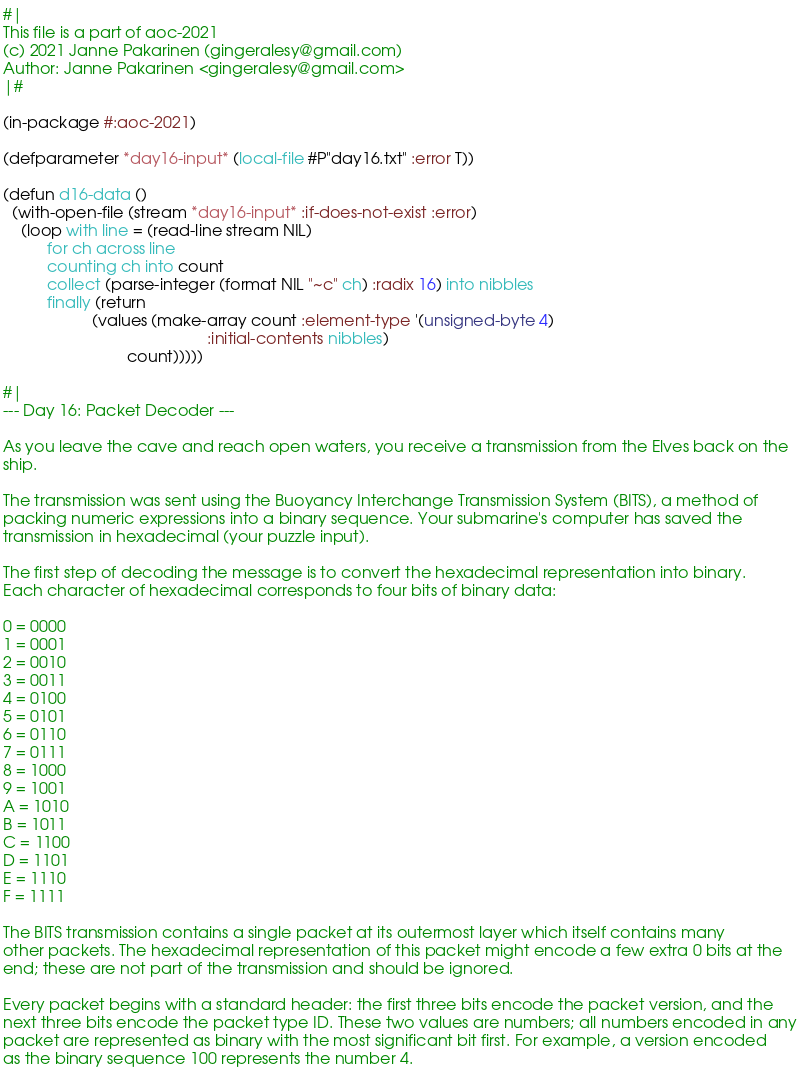<code> <loc_0><loc_0><loc_500><loc_500><_Lisp_>#|
This file is a part of aoc-2021
(c) 2021 Janne Pakarinen (gingeralesy@gmail.com)
Author: Janne Pakarinen <gingeralesy@gmail.com>
|#

(in-package #:aoc-2021)

(defparameter *day16-input* (local-file #P"day16.txt" :error T))

(defun d16-data ()
  (with-open-file (stream *day16-input* :if-does-not-exist :error)
    (loop with line = (read-line stream NIL)
          for ch across line
          counting ch into count
          collect (parse-integer (format NIL "~c" ch) :radix 16) into nibbles
          finally (return
                    (values (make-array count :element-type '(unsigned-byte 4)
                                              :initial-contents nibbles)
                            count)))))

#|
--- Day 16: Packet Decoder ---

As you leave the cave and reach open waters, you receive a transmission from the Elves back on the
ship.

The transmission was sent using the Buoyancy Interchange Transmission System (BITS), a method of
packing numeric expressions into a binary sequence. Your submarine's computer has saved the
transmission in hexadecimal (your puzzle input).

The first step of decoding the message is to convert the hexadecimal representation into binary.
Each character of hexadecimal corresponds to four bits of binary data:

0 = 0000
1 = 0001
2 = 0010
3 = 0011
4 = 0100
5 = 0101
6 = 0110
7 = 0111
8 = 1000
9 = 1001
A = 1010
B = 1011
C = 1100
D = 1101
E = 1110
F = 1111

The BITS transmission contains a single packet at its outermost layer which itself contains many
other packets. The hexadecimal representation of this packet might encode a few extra 0 bits at the
end; these are not part of the transmission and should be ignored.

Every packet begins with a standard header: the first three bits encode the packet version, and the
next three bits encode the packet type ID. These two values are numbers; all numbers encoded in any
packet are represented as binary with the most significant bit first. For example, a version encoded
as the binary sequence 100 represents the number 4.
</code> 